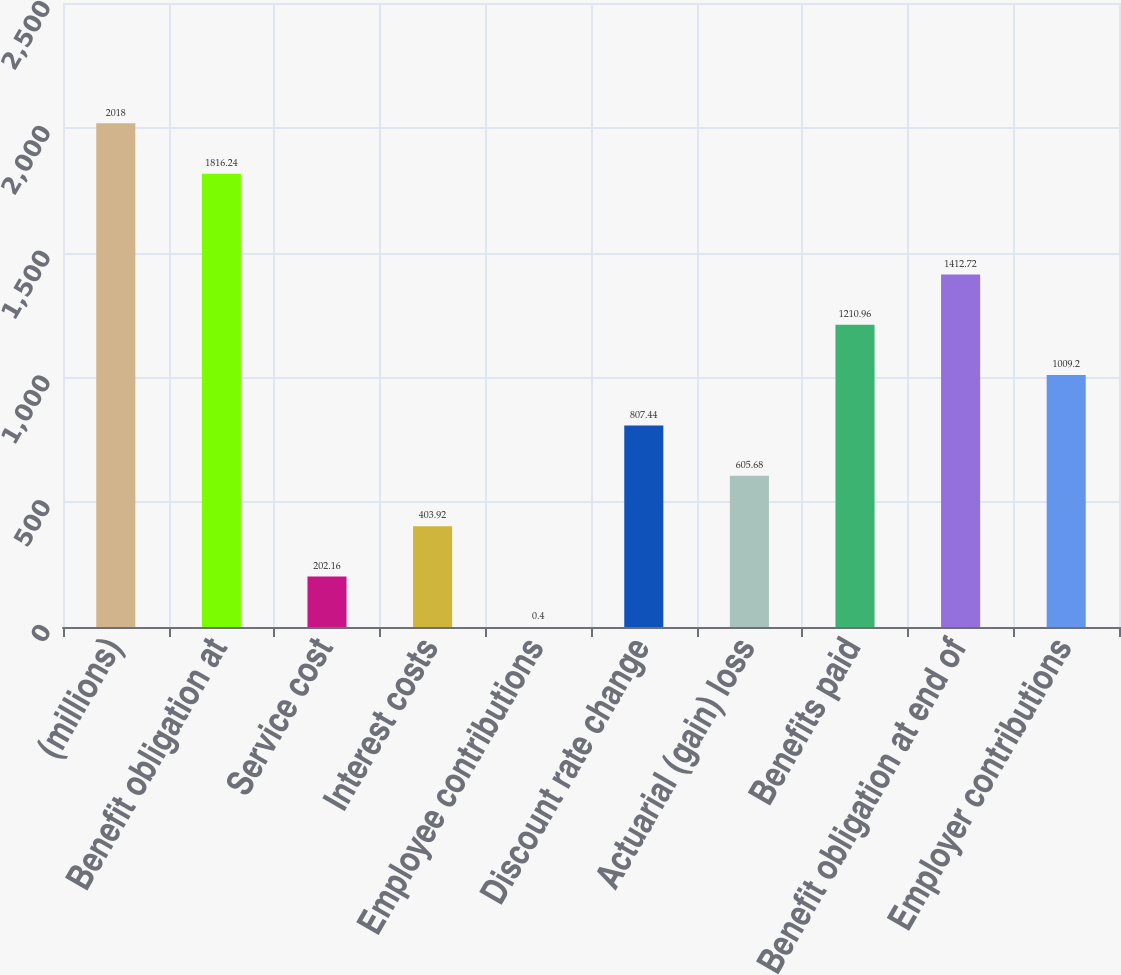<chart> <loc_0><loc_0><loc_500><loc_500><bar_chart><fcel>(millions)<fcel>Benefit obligation at<fcel>Service cost<fcel>Interest costs<fcel>Employee contributions<fcel>Discount rate change<fcel>Actuarial (gain) loss<fcel>Benefits paid<fcel>Benefit obligation at end of<fcel>Employer contributions<nl><fcel>2018<fcel>1816.24<fcel>202.16<fcel>403.92<fcel>0.4<fcel>807.44<fcel>605.68<fcel>1210.96<fcel>1412.72<fcel>1009.2<nl></chart> 